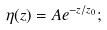Convert formula to latex. <formula><loc_0><loc_0><loc_500><loc_500>\eta ( z ) = A e ^ { - z / z _ { 0 } } ;</formula> 